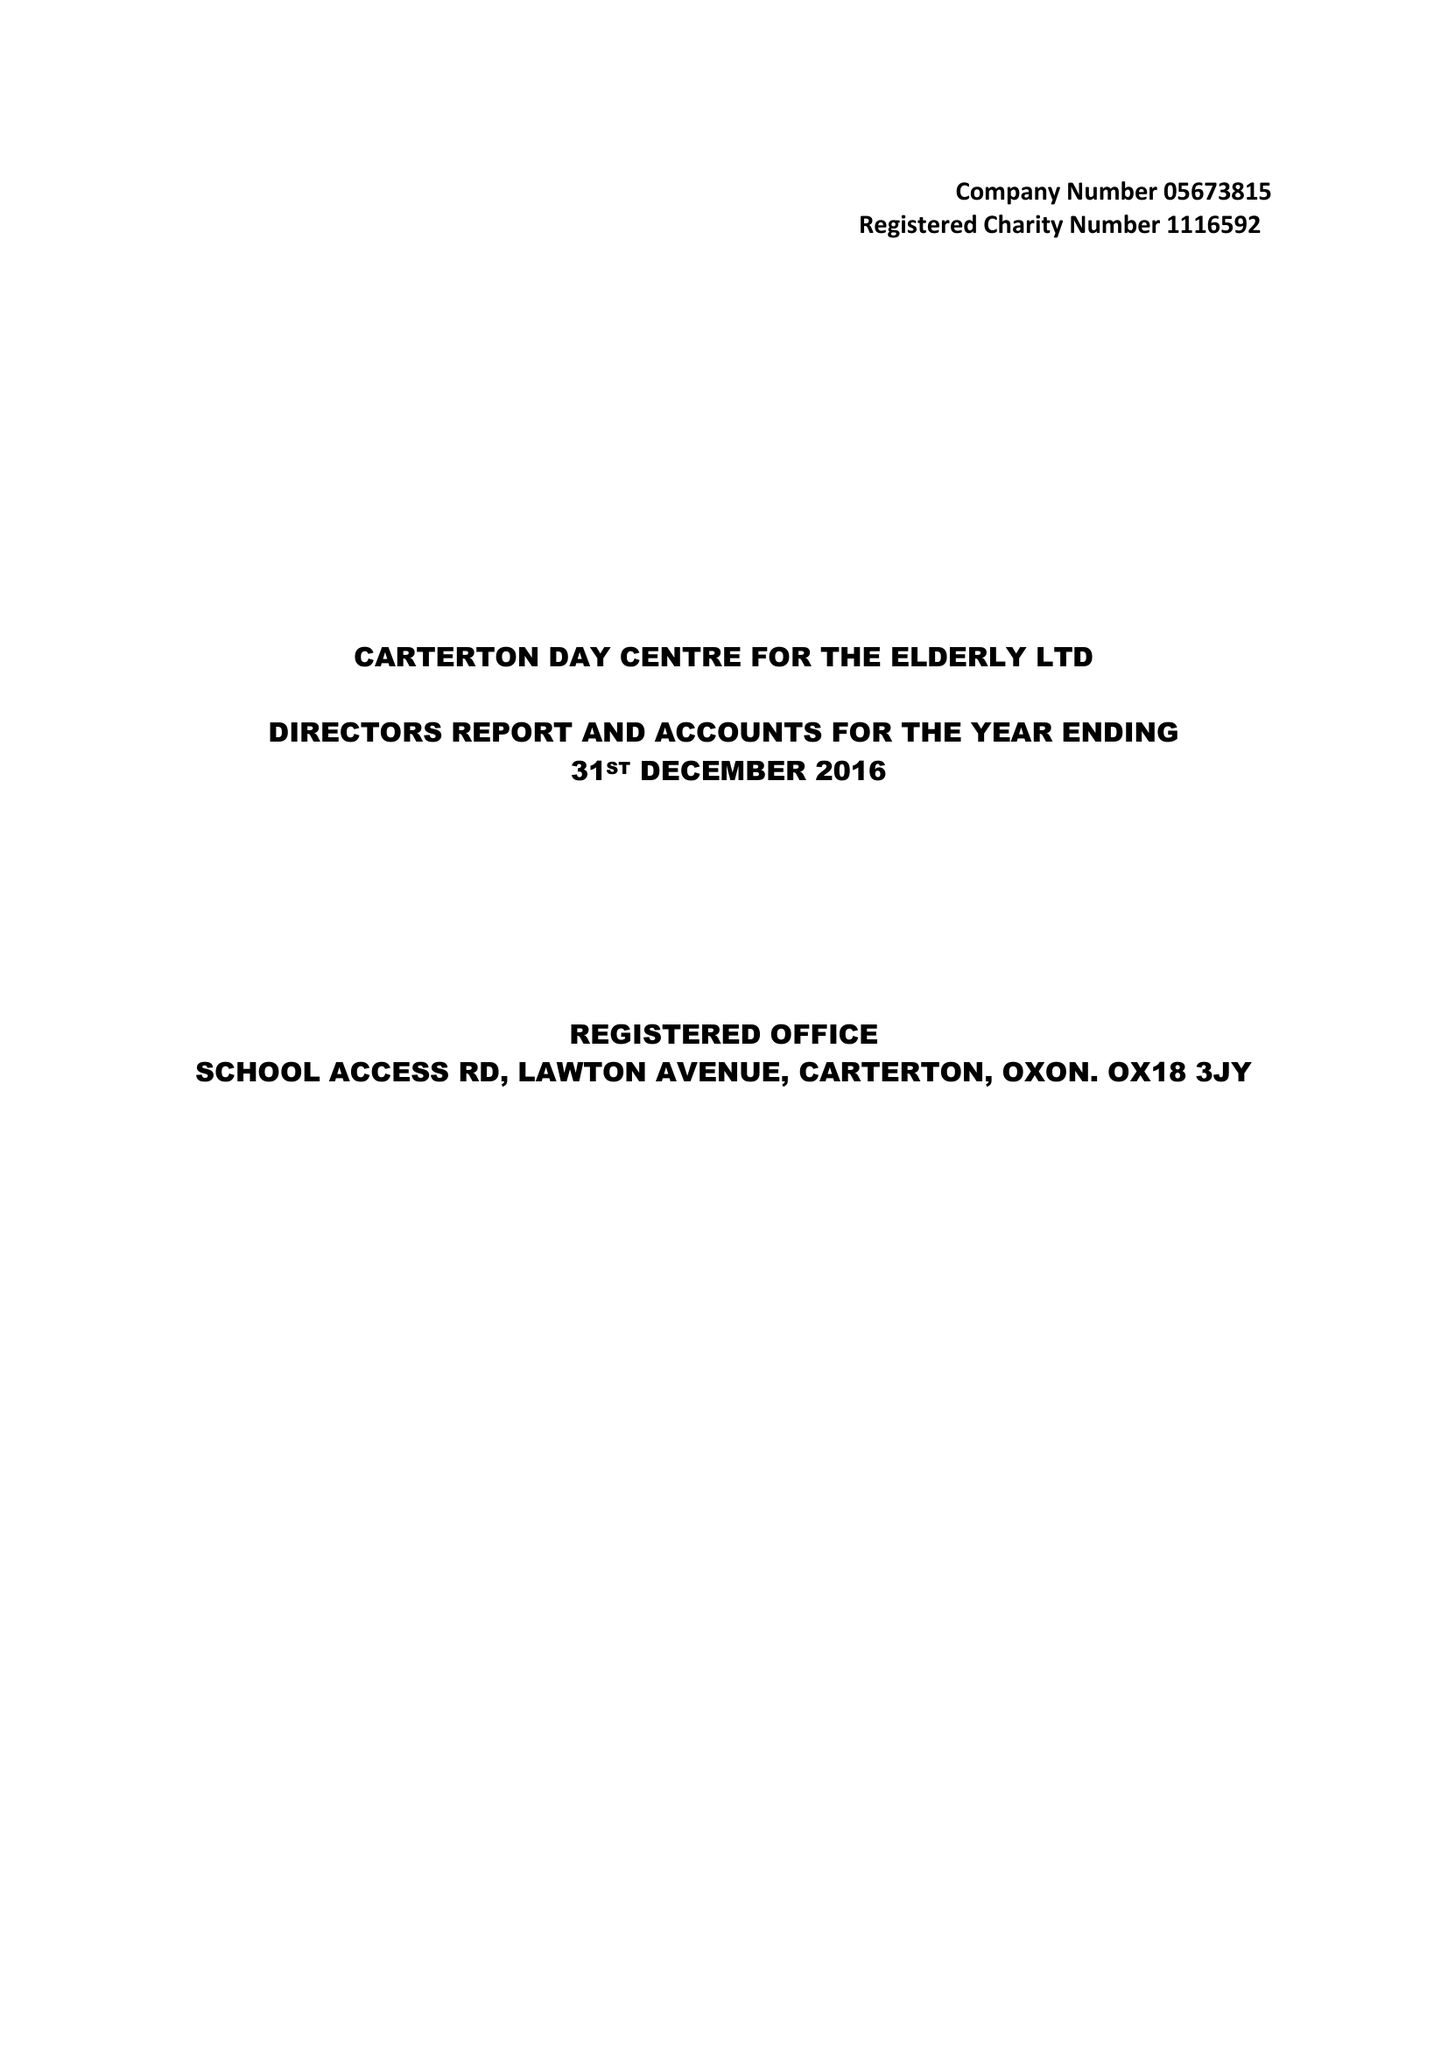What is the value for the address__post_town?
Answer the question using a single word or phrase. CARTERTON 